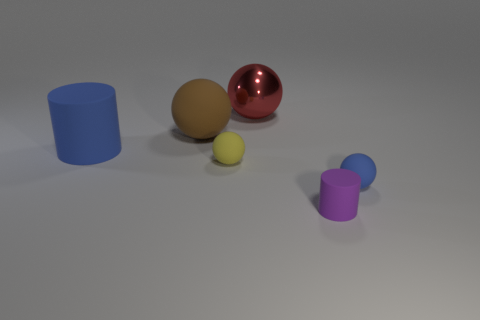Is the color of the ball to the right of the purple cylinder the same as the large cylinder?
Provide a succinct answer. Yes. Is the size of the purple cylinder the same as the yellow matte thing?
Offer a terse response. Yes. Is the color of the large cylinder the same as the sphere that is on the right side of the red ball?
Your response must be concise. Yes. There is a large thing that is the same material as the big cylinder; what shape is it?
Offer a terse response. Sphere. There is a blue matte object that is in front of the tiny yellow object; is its shape the same as the purple object?
Make the answer very short. No. How big is the cylinder behind the blue matte thing in front of the large blue thing?
Offer a terse response. Large. The large thing that is the same material as the large brown ball is what color?
Make the answer very short. Blue. What number of yellow matte objects have the same size as the purple rubber cylinder?
Your response must be concise. 1. How many blue things are either large metal things or large balls?
Provide a short and direct response. 0. How many things are small blue objects or balls in front of the large red sphere?
Provide a succinct answer. 3. 